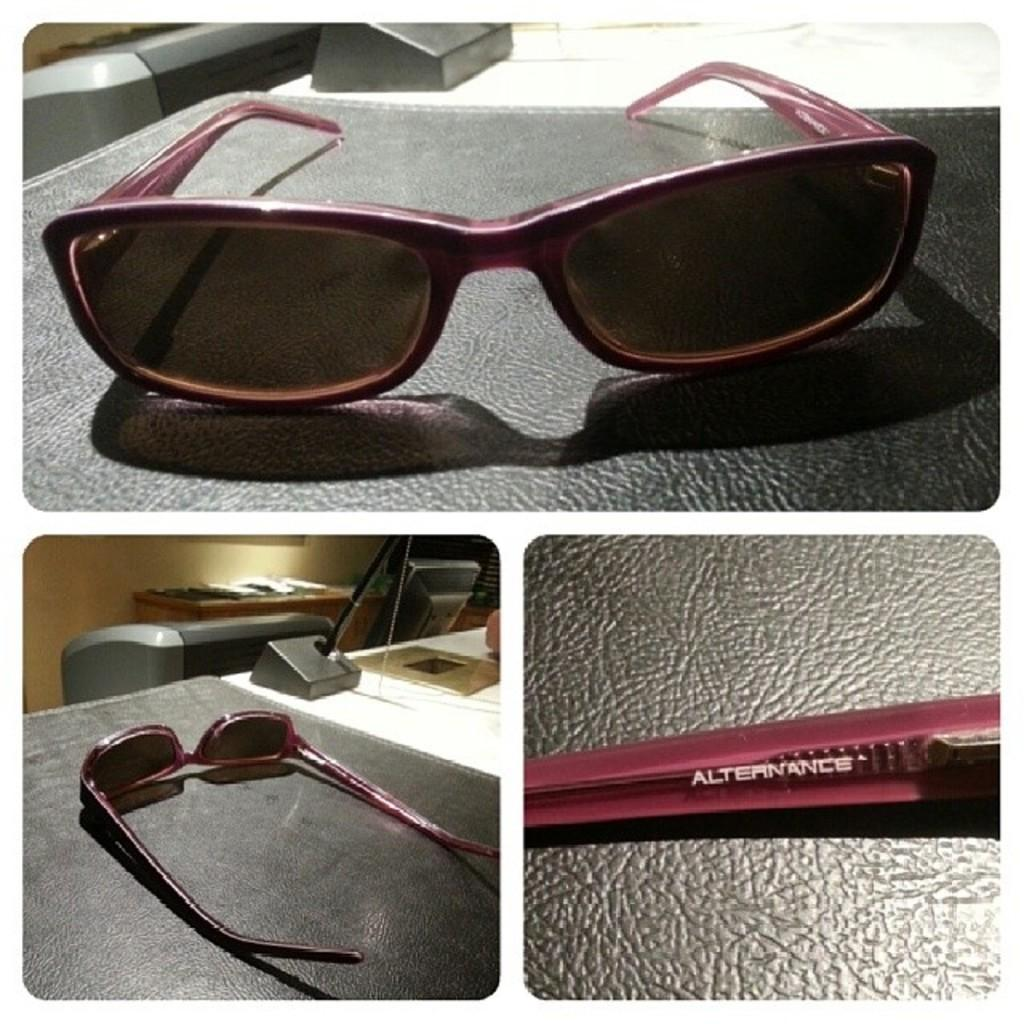What can be seen on the table in the image? There are glasses on a table in the image. Can you describe any other objects present in the image? Unfortunately, the provided facts only mention the presence of glasses on a table, so we cannot describe any other objects in the image. What type of noise can be heard coming from the glasses in the image? There is no indication of any noise in the image, as it only features glasses on a table. 